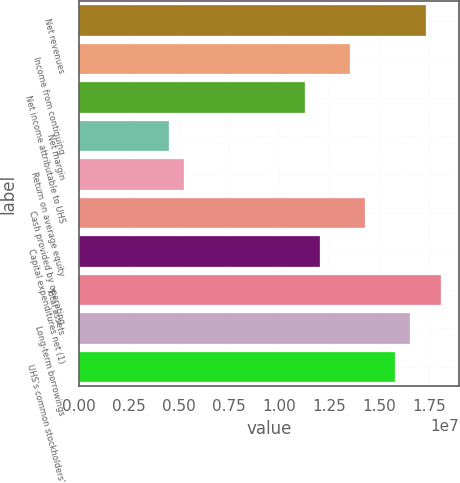Convert chart. <chart><loc_0><loc_0><loc_500><loc_500><bar_chart><fcel>Net revenues<fcel>Income from continuing<fcel>Net income attributable to UHS<fcel>Net margin<fcel>Return on average equity<fcel>Cash provided by operating<fcel>Capital expenditures net (1)<fcel>Total assets<fcel>Long-term borrowings<fcel>UHS's common stockholders'<nl><fcel>1.73143e+07<fcel>1.35503e+07<fcel>1.12919e+07<fcel>4.51676e+06<fcel>5.26956e+06<fcel>1.43031e+07<fcel>1.20447e+07<fcel>1.8067e+07<fcel>1.65615e+07<fcel>1.58087e+07<nl></chart> 